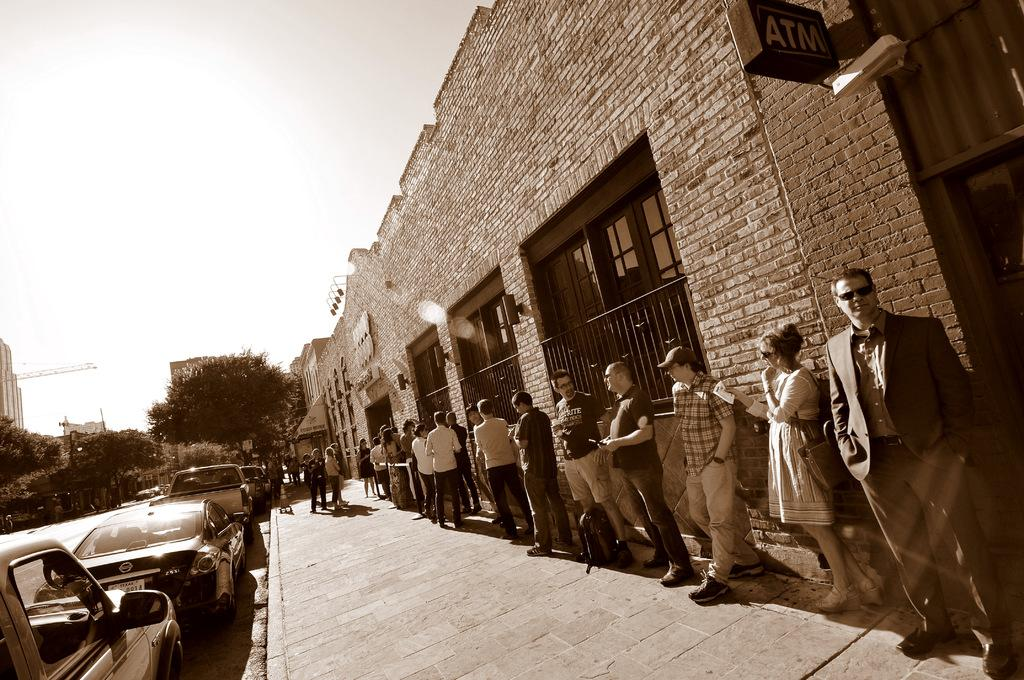What can be seen on the right side of the image? There are men standing on the right side of the image. Where are the men located in relation to the wall? The men are standing near a wall. What is visible on the left side of the image? There are parked cars on the left side of the image. What is visible at the top of the image? The sky is visible at the top of the image. What type of wire is being used to attack the parked cars in the image? There is no wire or attack present in the image; it features men standing near a wall and parked cars. How much salt is visible on the ground in the image? There is no salt visible on the ground in the image. 